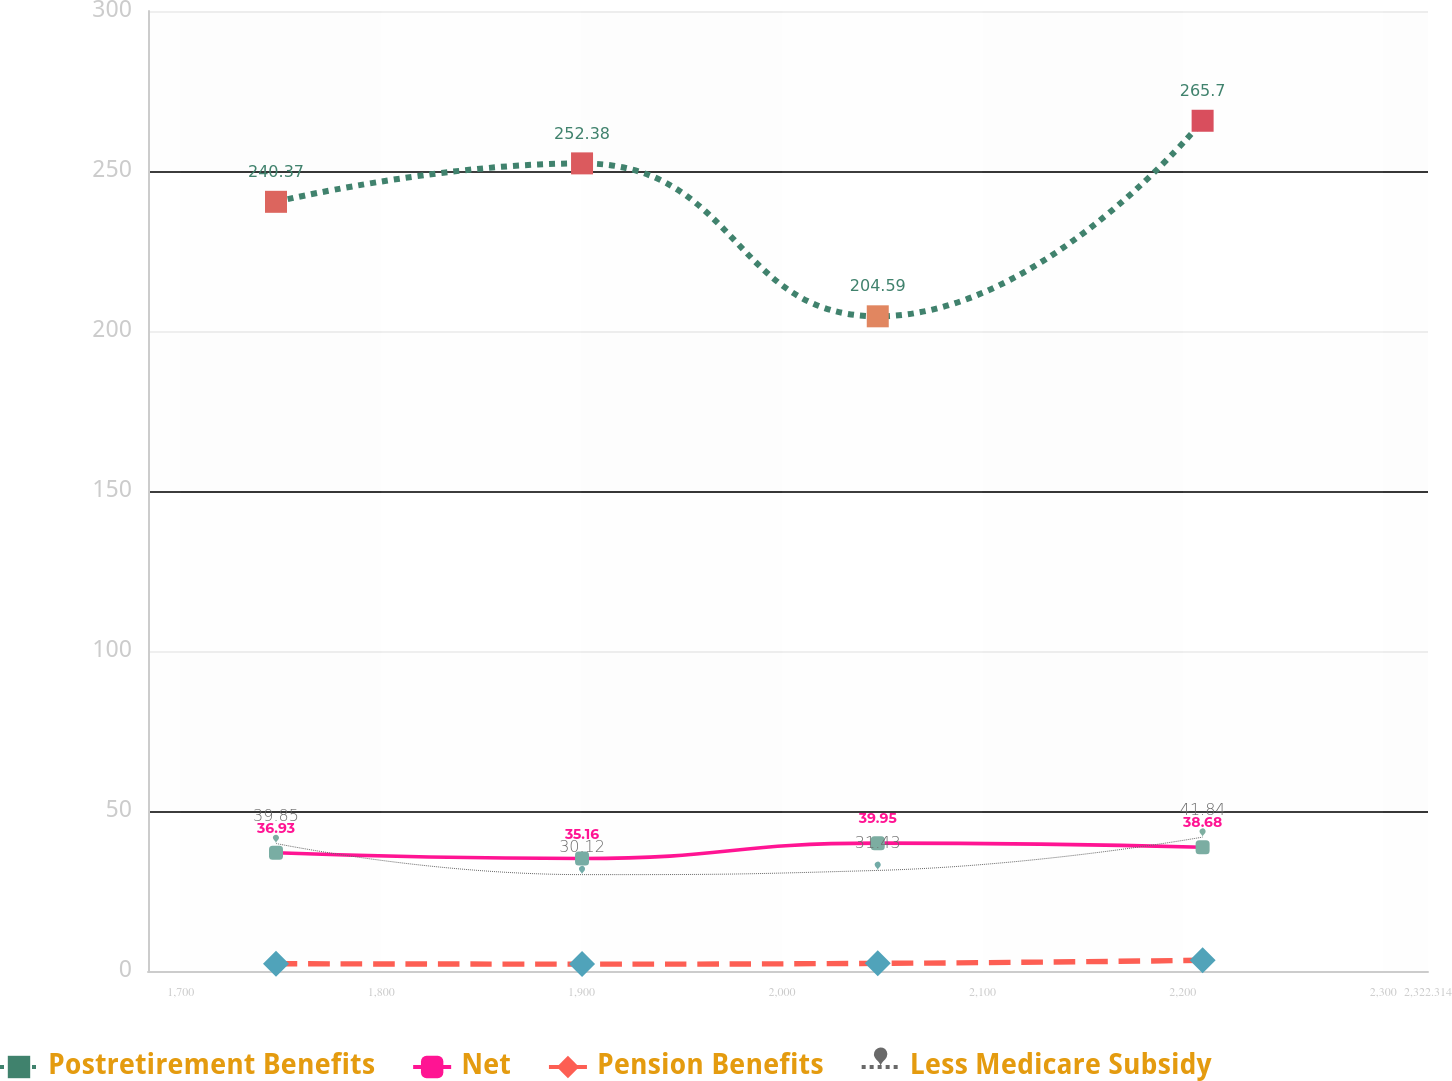Convert chart to OTSL. <chart><loc_0><loc_0><loc_500><loc_500><line_chart><ecel><fcel>Postretirement Benefits<fcel>Net<fcel>Pension Benefits<fcel>Less Medicare Subsidy<nl><fcel>1747.52<fcel>240.37<fcel>36.93<fcel>2.27<fcel>39.85<nl><fcel>1900.22<fcel>252.38<fcel>35.16<fcel>2.15<fcel>30.12<nl><fcel>2047.77<fcel>204.59<fcel>39.95<fcel>2.39<fcel>31.43<nl><fcel>2209.86<fcel>265.7<fcel>38.68<fcel>3.35<fcel>41.84<nl><fcel>2386.18<fcel>234.26<fcel>47.9<fcel>3<fcel>38.68<nl></chart> 